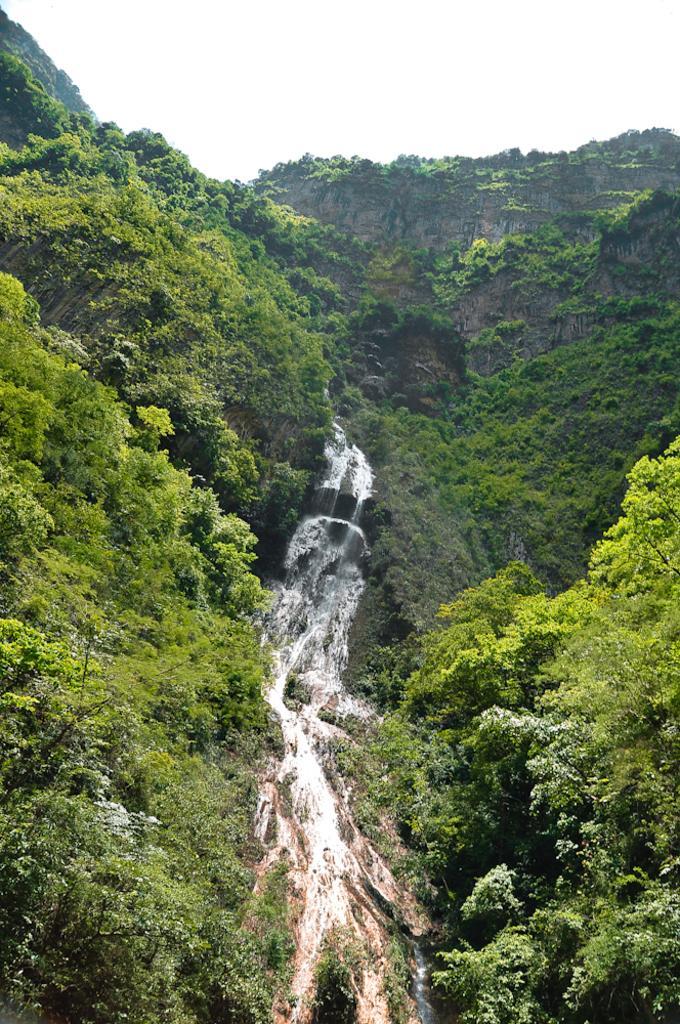How would you summarize this image in a sentence or two? In this image we can see the waterfall, on either side of the image we can see trees on the hills and the sky in the background. 